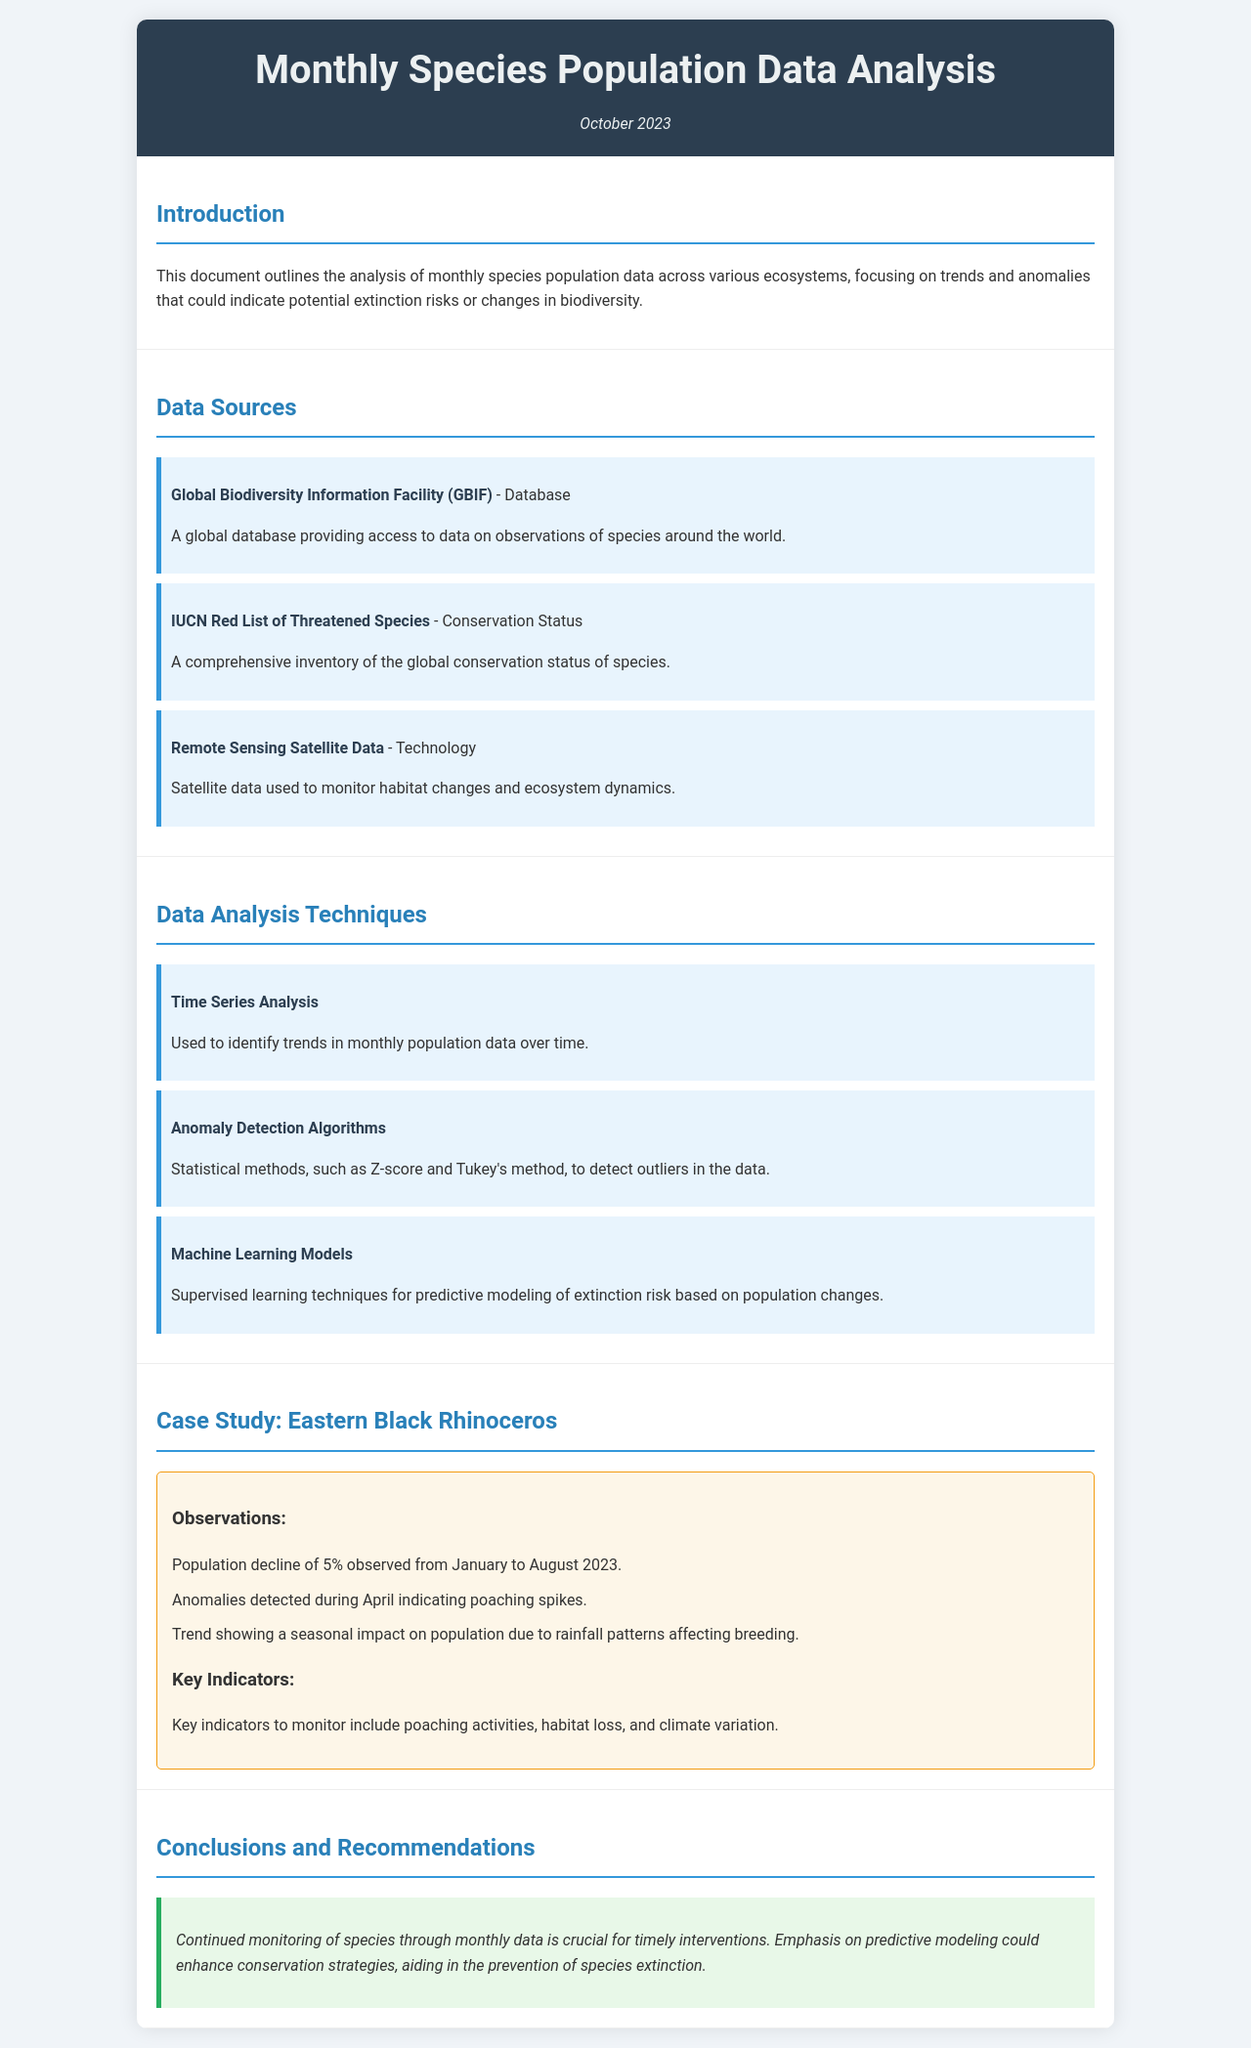what is the title of the document? The title of the document is stated in the header section, which is "Monthly Species Population Data Analysis."
Answer: Monthly Species Population Data Analysis what is the date of the analysis? The date of the analysis is indicated in the header as well, which is "October 2023."
Answer: October 2023 which species is highlighted in the case study? The case study section specifically mentions the "Eastern Black Rhinoceros."
Answer: Eastern Black Rhinoceros what percentage decline was observed in the population of the case study species? The document states a "5%" decline in population from January to August 2023.
Answer: 5% which algorithm is used for anomaly detection? The analysis technique section mentions "Z-score and Tukey's method" as statistical methods for anomaly detection.
Answer: Z-score and Tukey's method what is one of the key indicators to monitor for the Eastern Black Rhinoceros? The case study lists "poaching activities" as a key indicator to monitor.
Answer: poaching activities name one data source utilized in the analysis. The document lists "Global Biodiversity Information Facility (GBIF)" as one of the data sources.
Answer: Global Biodiversity Information Facility (GBIF) which analysis technique is mentioned for predictive modeling? The analysis techniques section refers to "Machine Learning Models" for predictive modeling purposes.
Answer: Machine Learning Models what is the conclusion regarding species monitoring? The conclusion states that "Continued monitoring of species through monthly data is crucial for timely interventions."
Answer: Continued monitoring of species through monthly data is crucial for timely interventions 